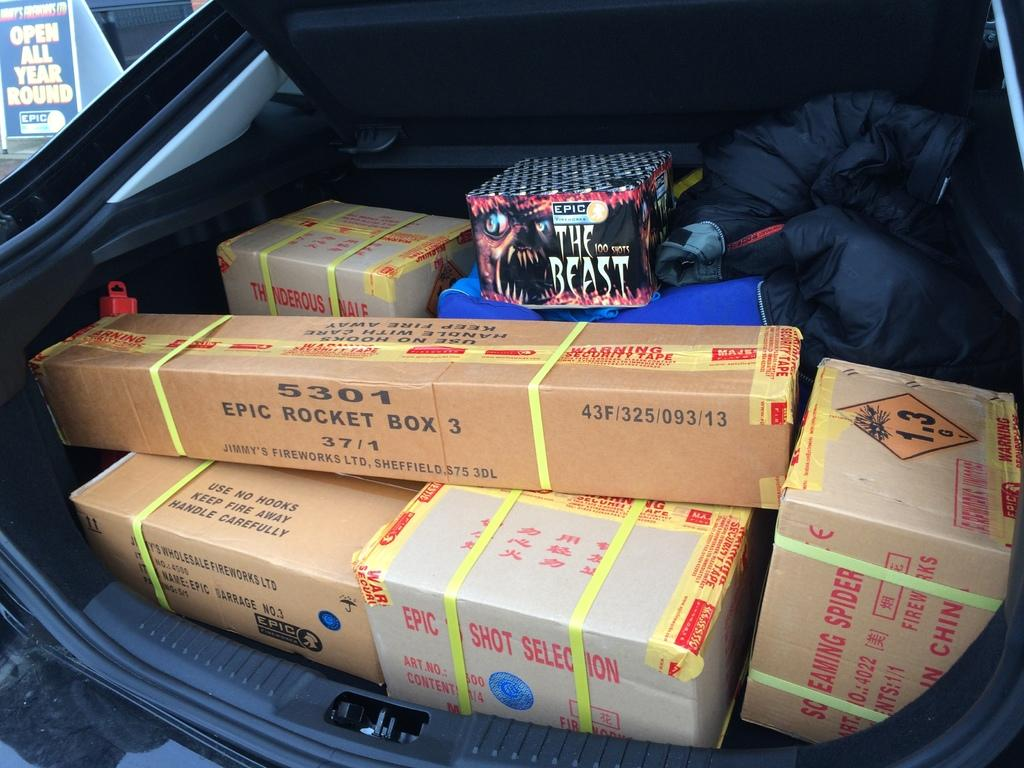What is the main subject of the image? The main subject of the image is a vehicle. What can be observed on the vehicle? The vehicle has a hickey, and there are boxes arranged in a black color jacket on it. What is visible in the background of the image? There is a hoarding in the background of the image. How much credit is available for the vehicle in the image? There is no information about credit available for the vehicle in the image. Can you see any honey dripping from the vehicle in the image? There is no honey present in the image. 